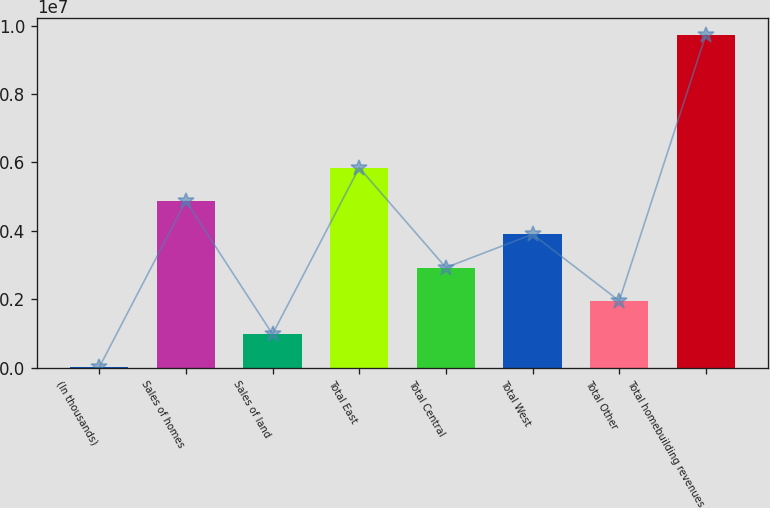<chart> <loc_0><loc_0><loc_500><loc_500><bar_chart><fcel>(In thousands)<fcel>Sales of homes<fcel>Sales of land<fcel>Total East<fcel>Total Central<fcel>Total West<fcel>Total Other<fcel>Total homebuilding revenues<nl><fcel>2016<fcel>4.87168e+06<fcel>975948<fcel>5.84561e+06<fcel>2.92381e+06<fcel>3.89774e+06<fcel>1.94988e+06<fcel>9.74134e+06<nl></chart> 